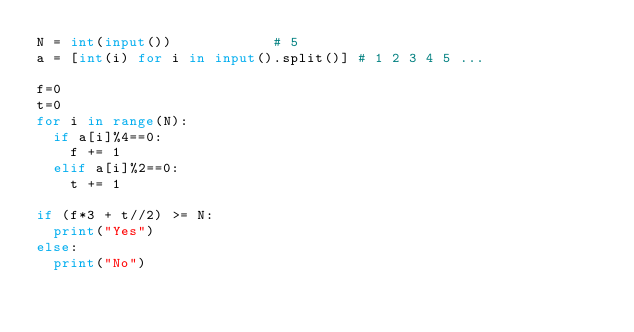<code> <loc_0><loc_0><loc_500><loc_500><_Python_>N = int(input())						# 5
a = [int(i) for i in input().split()]	# 1 2 3 4 5 ...

f=0
t=0
for i in range(N):
	if a[i]%4==0:
		f += 1
	elif a[i]%2==0:
		t += 1

if (f*3 + t//2) >= N:
	print("Yes")
else:
	print("No")


</code> 